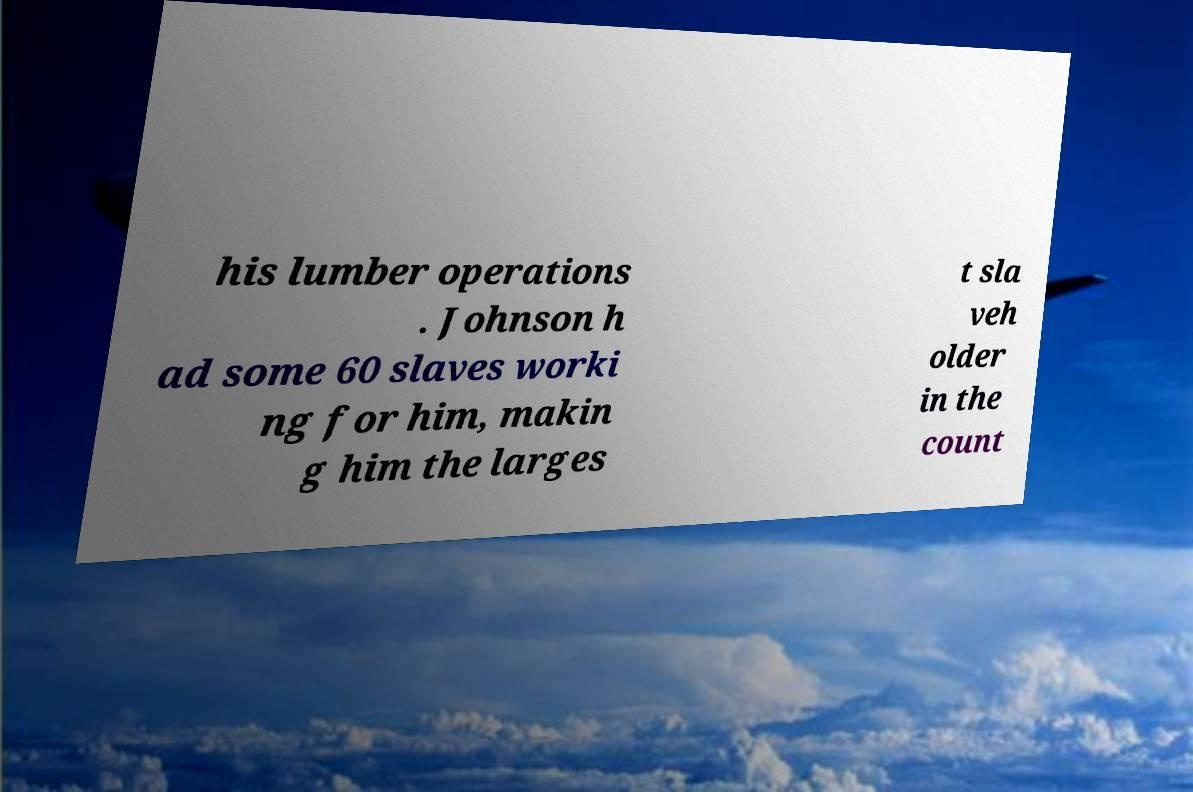What messages or text are displayed in this image? I need them in a readable, typed format. his lumber operations . Johnson h ad some 60 slaves worki ng for him, makin g him the larges t sla veh older in the count 